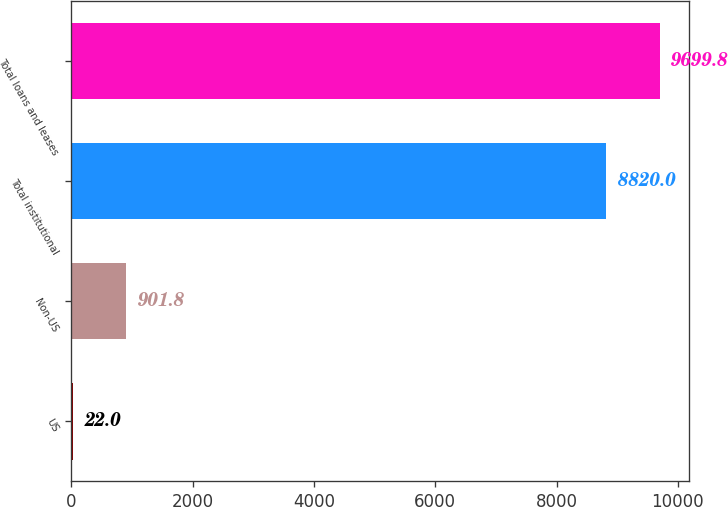Convert chart. <chart><loc_0><loc_0><loc_500><loc_500><bar_chart><fcel>US<fcel>Non-US<fcel>Total institutional<fcel>Total loans and leases<nl><fcel>22<fcel>901.8<fcel>8820<fcel>9699.8<nl></chart> 